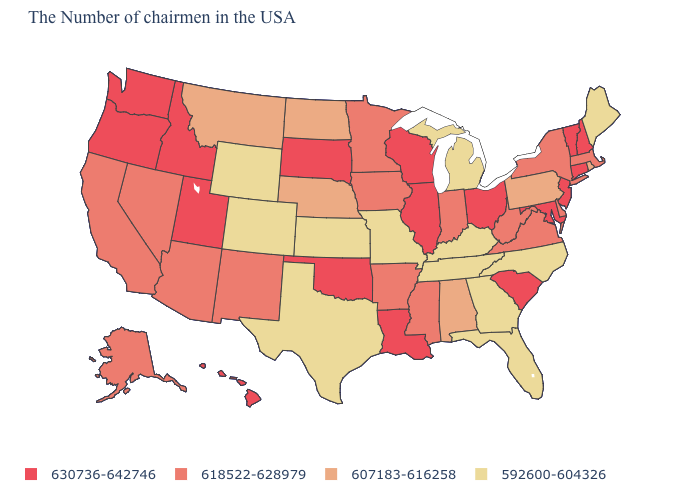Which states have the lowest value in the Northeast?
Keep it brief. Maine. What is the value of Maryland?
Be succinct. 630736-642746. What is the value of Texas?
Concise answer only. 592600-604326. Does Connecticut have a higher value than Georgia?
Write a very short answer. Yes. Name the states that have a value in the range 630736-642746?
Quick response, please. New Hampshire, Vermont, Connecticut, New Jersey, Maryland, South Carolina, Ohio, Wisconsin, Illinois, Louisiana, Oklahoma, South Dakota, Utah, Idaho, Washington, Oregon, Hawaii. Does the map have missing data?
Short answer required. No. Name the states that have a value in the range 607183-616258?
Quick response, please. Rhode Island, Pennsylvania, Alabama, Nebraska, North Dakota, Montana. Name the states that have a value in the range 592600-604326?
Short answer required. Maine, North Carolina, Florida, Georgia, Michigan, Kentucky, Tennessee, Missouri, Kansas, Texas, Wyoming, Colorado. Name the states that have a value in the range 592600-604326?
Short answer required. Maine, North Carolina, Florida, Georgia, Michigan, Kentucky, Tennessee, Missouri, Kansas, Texas, Wyoming, Colorado. What is the value of North Carolina?
Be succinct. 592600-604326. Which states hav the highest value in the West?
Quick response, please. Utah, Idaho, Washington, Oregon, Hawaii. Does Virginia have the highest value in the South?
Write a very short answer. No. Does Maryland have the lowest value in the South?
Be succinct. No. Among the states that border Delaware , which have the lowest value?
Be succinct. Pennsylvania. Among the states that border New Hampshire , does Massachusetts have the highest value?
Short answer required. No. 